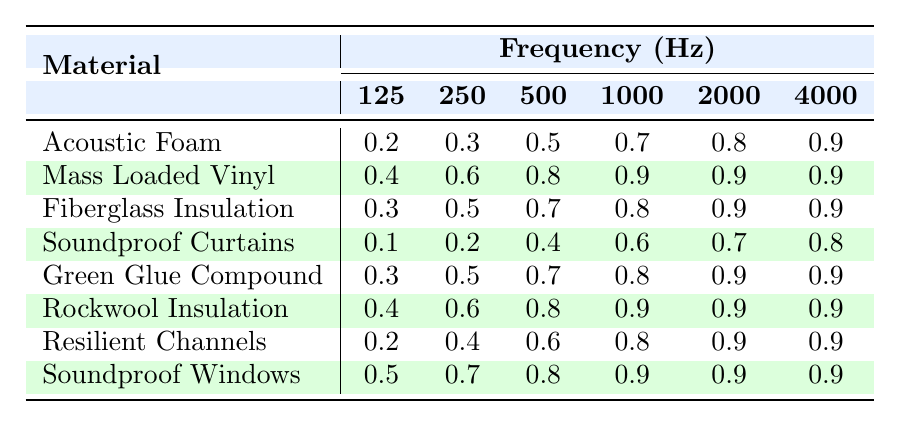What is the effectiveness rating of Acoustic Foam at 1000 Hz? Looking at the row for Acoustic Foam, the rating for 1000 Hz is the fourth value in that row, which is 0.7.
Answer: 0.7 Which material has the highest effectiveness rating at 4000 Hz? Checking the last column for the effectiveness ratings at 4000 Hz, I can see that Soundproof Windows has the highest rating of 0.9.
Answer: Soundproof Windows What is the average effectiveness rating of Mass Loaded Vinyl across all frequencies? To find the average, I first sum the ratings: 0.4 + 0.6 + 0.8 + 0.9 + 0.9 + 0.9 = 4.5. Then I divide by the number of frequencies, which is 6. Thus, the average is 4.5 / 6 = 0.75.
Answer: 0.75 Is the effectiveness rating of Rockwool Insulation at 2000 Hz greater than 0.8? Looking at the row for Rockwool Insulation, the rating at 2000 Hz is 0.9, which is indeed greater than 0.8.
Answer: Yes What is the difference in effectiveness ratings at 125 Hz between Soundproof Curtains and Soundproof Windows? For Soundproof Curtains, the rating at 125 Hz is 0.1, and for Soundproof Windows, it is 0.5. The difference is 0.5 - 0.1 = 0.4.
Answer: 0.4 Which material has the lowest effectiveness rating at 500 Hz? By comparing the values in the 500 Hz column, Soundproof Curtains has the lowest rating of 0.4.
Answer: Soundproof Curtains If we consider only the top three materials with the highest average effectiveness ratings, what are they? Calculating the averages gives: Mass Loaded Vinyl (0.8), Rockwool Insulation (0.8), and Soundproof Windows (0.8). All three tie for the highest, meaning they share this ranking.
Answer: Mass Loaded Vinyl, Rockwool Insulation, Soundproof Windows What is the total effectiveness rating of Fiberglass Insulation at all frequencies? For Fiberglass Insulation, the ratings are 0.3, 0.5, 0.7, 0.8, 0.9, and 0.9. Adding these gives 0.3 + 0.5 + 0.7 + 0.8 + 0.9 + 0.9 = 4.1.
Answer: 4.1 At which frequency does Green Glue Compound show the same effectiveness rating as Fiberglass Insulation? Comparing the ratings: at 125 Hz, both have 0.3; at 250 Hz, both have 0.5. Therefore, they match at two frequencies: 125 Hz and 250 Hz.
Answer: 125 Hz and 250 Hz Which material would you recommend for maximum noise reduction at 1000 Hz? Checking the rating at 1000 Hz, Soundproof Windows has the highest rating of 0.9, making it the best choice for noise reduction at this frequency.
Answer: Soundproof Windows 